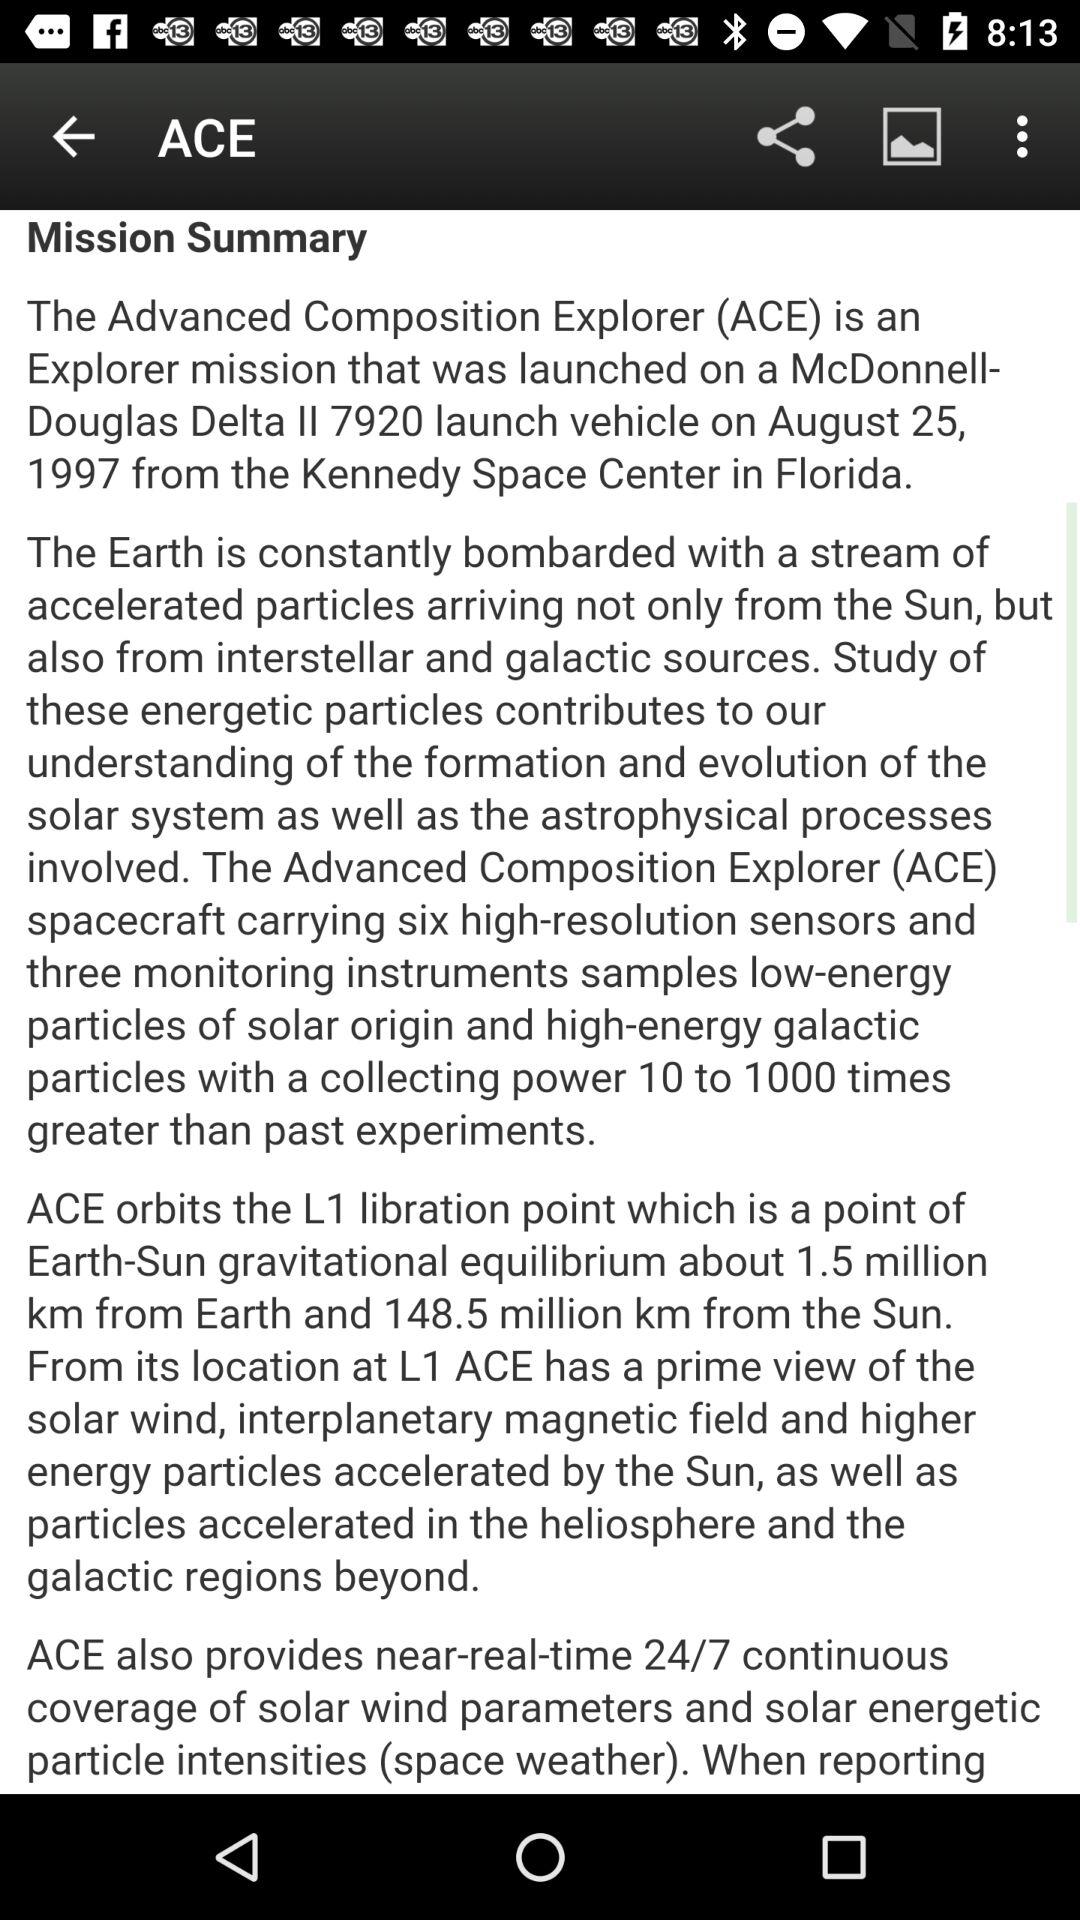From where did the "ACE Spacecraft" launch? It was launched from the "Kennedy Space Center". 